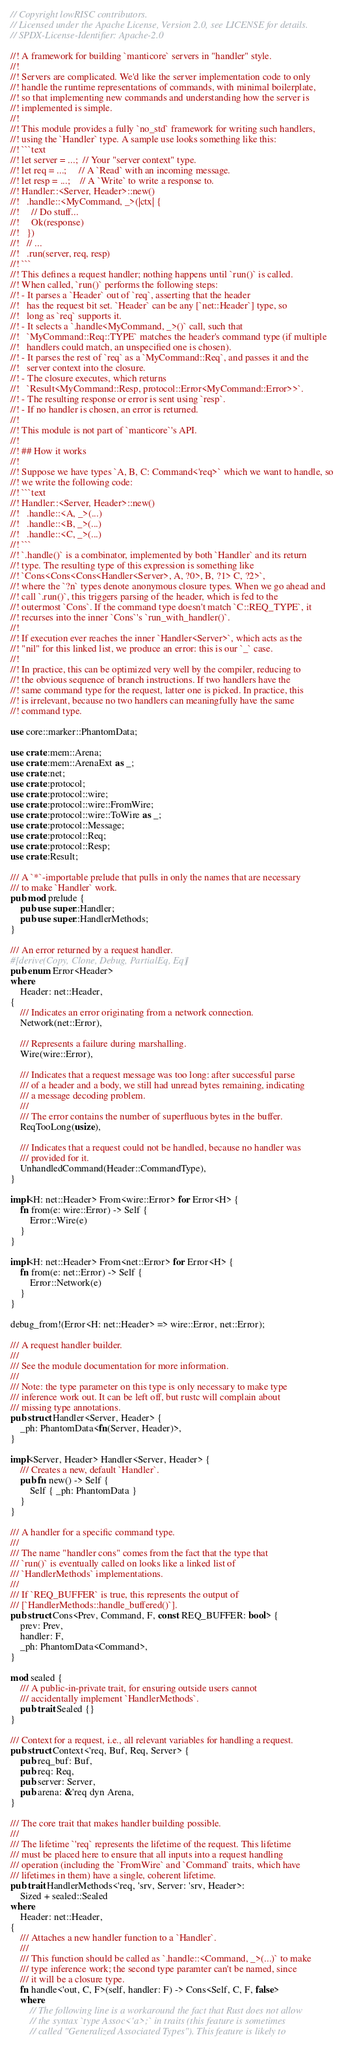<code> <loc_0><loc_0><loc_500><loc_500><_Rust_>// Copyright lowRISC contributors.
// Licensed under the Apache License, Version 2.0, see LICENSE for details.
// SPDX-License-Identifier: Apache-2.0

//! A framework for building `manticore` servers in "handler" style.
//!
//! Servers are complicated. We'd like the server implementation code to only
//! handle the runtime representations of commands, with minimal boilerplate,
//! so that implementing new commands and understanding how the server is
//! implemented is simple.
//!
//! This module provides a fully `no_std` framework for writing such handlers,
//! using the `Handler` type. A sample use looks something like this:
//! ```text
//! let server = ...;  // Your "server context" type.
//! let req = ...;     // A `Read` with an incoming message.
//! let resp = ...;    // A `Write` to write a response to.
//! Handler::<Server, Header>::new()
//!   .handle::<MyCommand, _>(|ctx| {
//!     // Do stuff...
//!     Ok(response)
//!   })
//!   // ...
//!   .run(server, req, resp)
//! ```
//! This defines a request handler; nothing happens until `run()` is called.
//! When called, `run()` performs the following steps:
//! - It parses a `Header` out of `req`, asserting that the header
//!   has the request bit set. `Header` can be any [`net::Header`] type, so
//!   long as `req` supports it.
//! - It selects a `.handle<MyCommand, _>()` call, such that
//!   `MyCommand::Req::TYPE` matches the header's command type (if multiple
//!   handlers could match, an unspecified one is chosen).
//! - It parses the rest of `req` as a `MyCommand::Req`, and passes it and the
//!   server context into the closure.
//! - The closure executes, which returns
//!   `Result<MyCommand::Resp, protocol::Error<MyCommand::Error>>`.
//! - The resulting response or error is sent using `resp`.
//! - If no handler is chosen, an error is returned.
//!
//! This module is not part of `manticore`'s API.
//!
//! ## How it works
//!
//! Suppose we have types `A, B, C: Command<'req>` which we want to handle, so
//! we write the following code:
//! ```text
//! Handler::<Server, Header>::new()
//!   .handle::<A, _>(...)
//!   .handle::<B, _>(...)
//!   .handle::<C, _>(...)
//! ```
//! `.handle()` is a combinator, implemented by both `Handler` and its return
//! type. The resulting type of this expression is something like
//! `Cons<Cons<Cons<Handler<Server>, A, ?0>, B, ?1> C, ?2>`,
//! where the `?n` types denote anonymous closure types. When we go ahead and
//! call `.run()`, this triggers parsing of the header, which is fed to the
//! outermost `Cons`. If the command type doesn't match `C::REQ_TYPE`, it
//! recurses into the inner `Cons`'s `run_with_handler()`.
//!
//! If execution ever reaches the inner `Handler<Server>`, which acts as the
//! "nil" for this linked list, we produce an error: this is our `_` case.
//!
//! In practice, this can be optimized very well by the compiler, reducing to
//! the obvious sequence of branch instructions. If two handlers have the
//! same command type for the request, latter one is picked. In practice, this
//! is irrelevant, because no two handlers can meaningfully have the same
//! command type.

use core::marker::PhantomData;

use crate::mem::Arena;
use crate::mem::ArenaExt as _;
use crate::net;
use crate::protocol;
use crate::protocol::wire;
use crate::protocol::wire::FromWire;
use crate::protocol::wire::ToWire as _;
use crate::protocol::Message;
use crate::protocol::Req;
use crate::protocol::Resp;
use crate::Result;

/// A `*`-importable prelude that pulls in only the names that are necessary
/// to make `Handler` work.
pub mod prelude {
    pub use super::Handler;
    pub use super::HandlerMethods;
}

/// An error returned by a request handler.
#[derive(Copy, Clone, Debug, PartialEq, Eq)]
pub enum Error<Header>
where
    Header: net::Header,
{
    /// Indicates an error originating from a network connection.
    Network(net::Error),

    /// Represents a failure during marshalling.
    Wire(wire::Error),

    /// Indicates that a request message was too long: after successful parse
    /// of a header and a body, we still had unread bytes remaining, indicating
    /// a message decoding problem.
    ///
    /// The error contains the number of superfluous bytes in the buffer.
    ReqTooLong(usize),

    /// Indicates that a request could not be handled, because no handler was
    /// provided for it.
    UnhandledCommand(Header::CommandType),
}

impl<H: net::Header> From<wire::Error> for Error<H> {
    fn from(e: wire::Error) -> Self {
        Error::Wire(e)
    }
}

impl<H: net::Header> From<net::Error> for Error<H> {
    fn from(e: net::Error) -> Self {
        Error::Network(e)
    }
}

debug_from!(Error<H: net::Header> => wire::Error, net::Error);

/// A request handler builder.
///
/// See the module documentation for more information.
///
/// Note: the type parameter on this type is only necessary to make type
/// inference work out. It can be left off, but rustc will complain about
/// missing type annotations.
pub struct Handler<Server, Header> {
    _ph: PhantomData<fn(Server, Header)>,
}

impl<Server, Header> Handler<Server, Header> {
    /// Creates a new, default `Handler`.
    pub fn new() -> Self {
        Self { _ph: PhantomData }
    }
}

/// A handler for a specific command type.
///
/// The name "handler cons" comes from the fact that the type that
/// `run()` is eventually called on looks like a linked list of
/// `HandlerMethods` implementations.
///
/// If `REQ_BUFFER` is true, this represents the output of
/// [`HandlerMethods::handle_buffered()`].
pub struct Cons<Prev, Command, F, const REQ_BUFFER: bool> {
    prev: Prev,
    handler: F,
    _ph: PhantomData<Command>,
}

mod sealed {
    /// A public-in-private trait, for ensuring outside users cannot
    /// accidentally implement `HandlerMethods`.
    pub trait Sealed {}
}

/// Context for a request, i.e., all relevant variables for handling a request.
pub struct Context<'req, Buf, Req, Server> {
    pub req_buf: Buf,
    pub req: Req,
    pub server: Server,
    pub arena: &'req dyn Arena,
}

/// The core trait that makes handler building possible.
///
/// The lifetime `'req` represents the lifetime of the request. This lifetime
/// must be placed here to ensure that all inputs into a request handling
/// operation (including the `FromWire` and `Command` traits, which have
/// lifetimes in them) have a single, coherent lifetime.
pub trait HandlerMethods<'req, 'srv, Server: 'srv, Header>:
    Sized + sealed::Sealed
where
    Header: net::Header,
{
    /// Attaches a new handler function to a `Handler`.
    ///
    /// This function should be called as `.handle::<Command, _>(...)` to make
    /// type inference work; the second type paramter can't be named, since
    /// it will be a closure type.
    fn handle<'out, C, F>(self, handler: F) -> Cons<Self, C, F, false>
    where
        // The following line is a workaround the fact that Rust does not allow
        // the syntax `type Assoc<'a>;` in traits (this feature is sometimes
        // called "Generalized Associated Types"). This feature is likely to</code> 